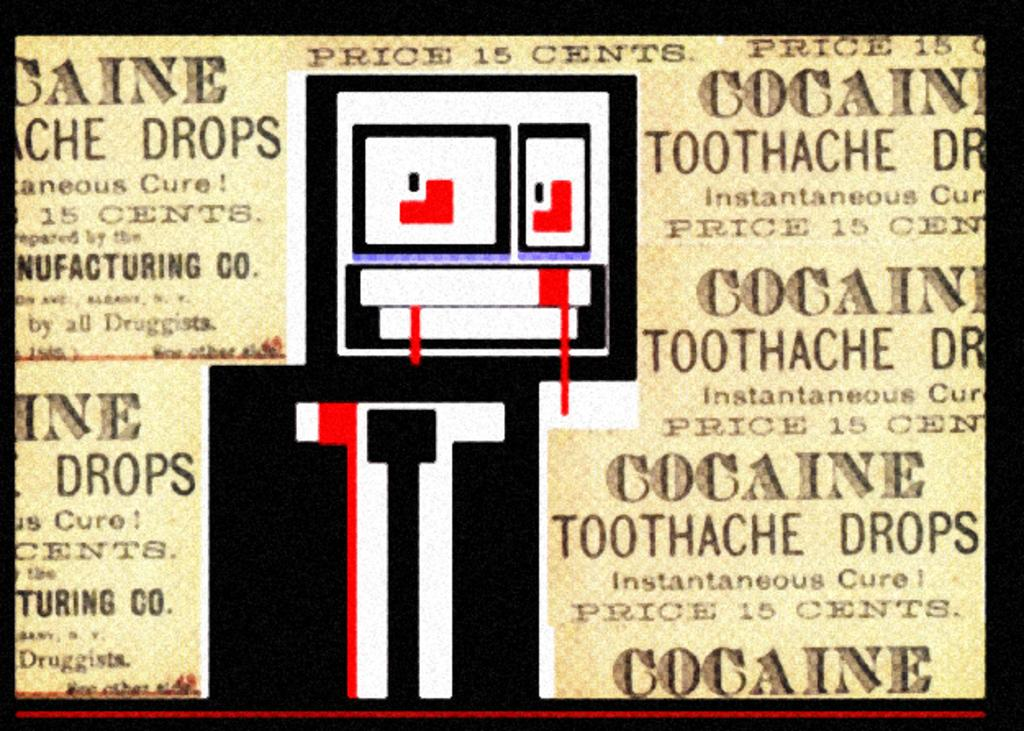Provide a one-sentence caption for the provided image. An advertisement for toothache drops that contain cocaine. 